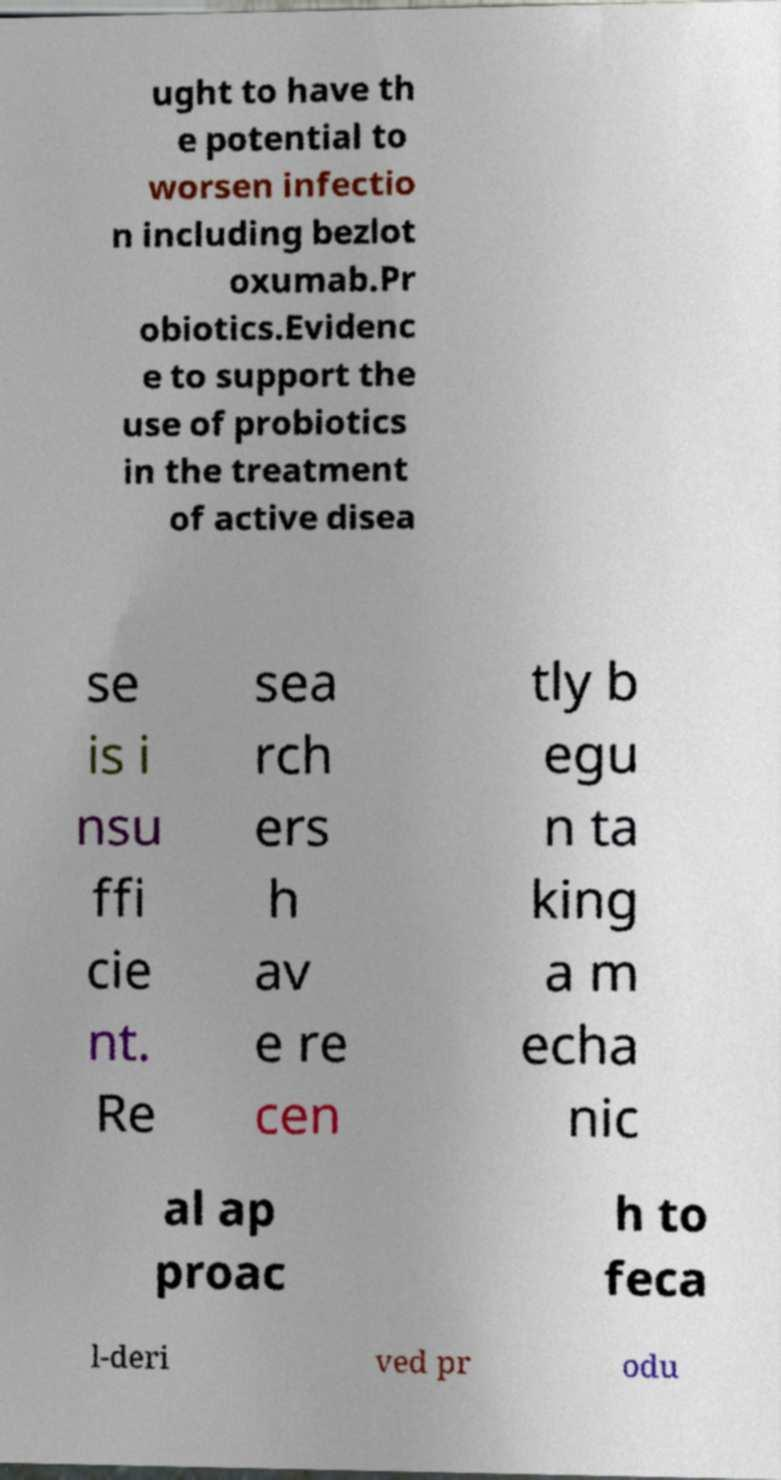Please read and relay the text visible in this image. What does it say? ught to have th e potential to worsen infectio n including bezlot oxumab.Pr obiotics.Evidenc e to support the use of probiotics in the treatment of active disea se is i nsu ffi cie nt. Re sea rch ers h av e re cen tly b egu n ta king a m echa nic al ap proac h to feca l-deri ved pr odu 